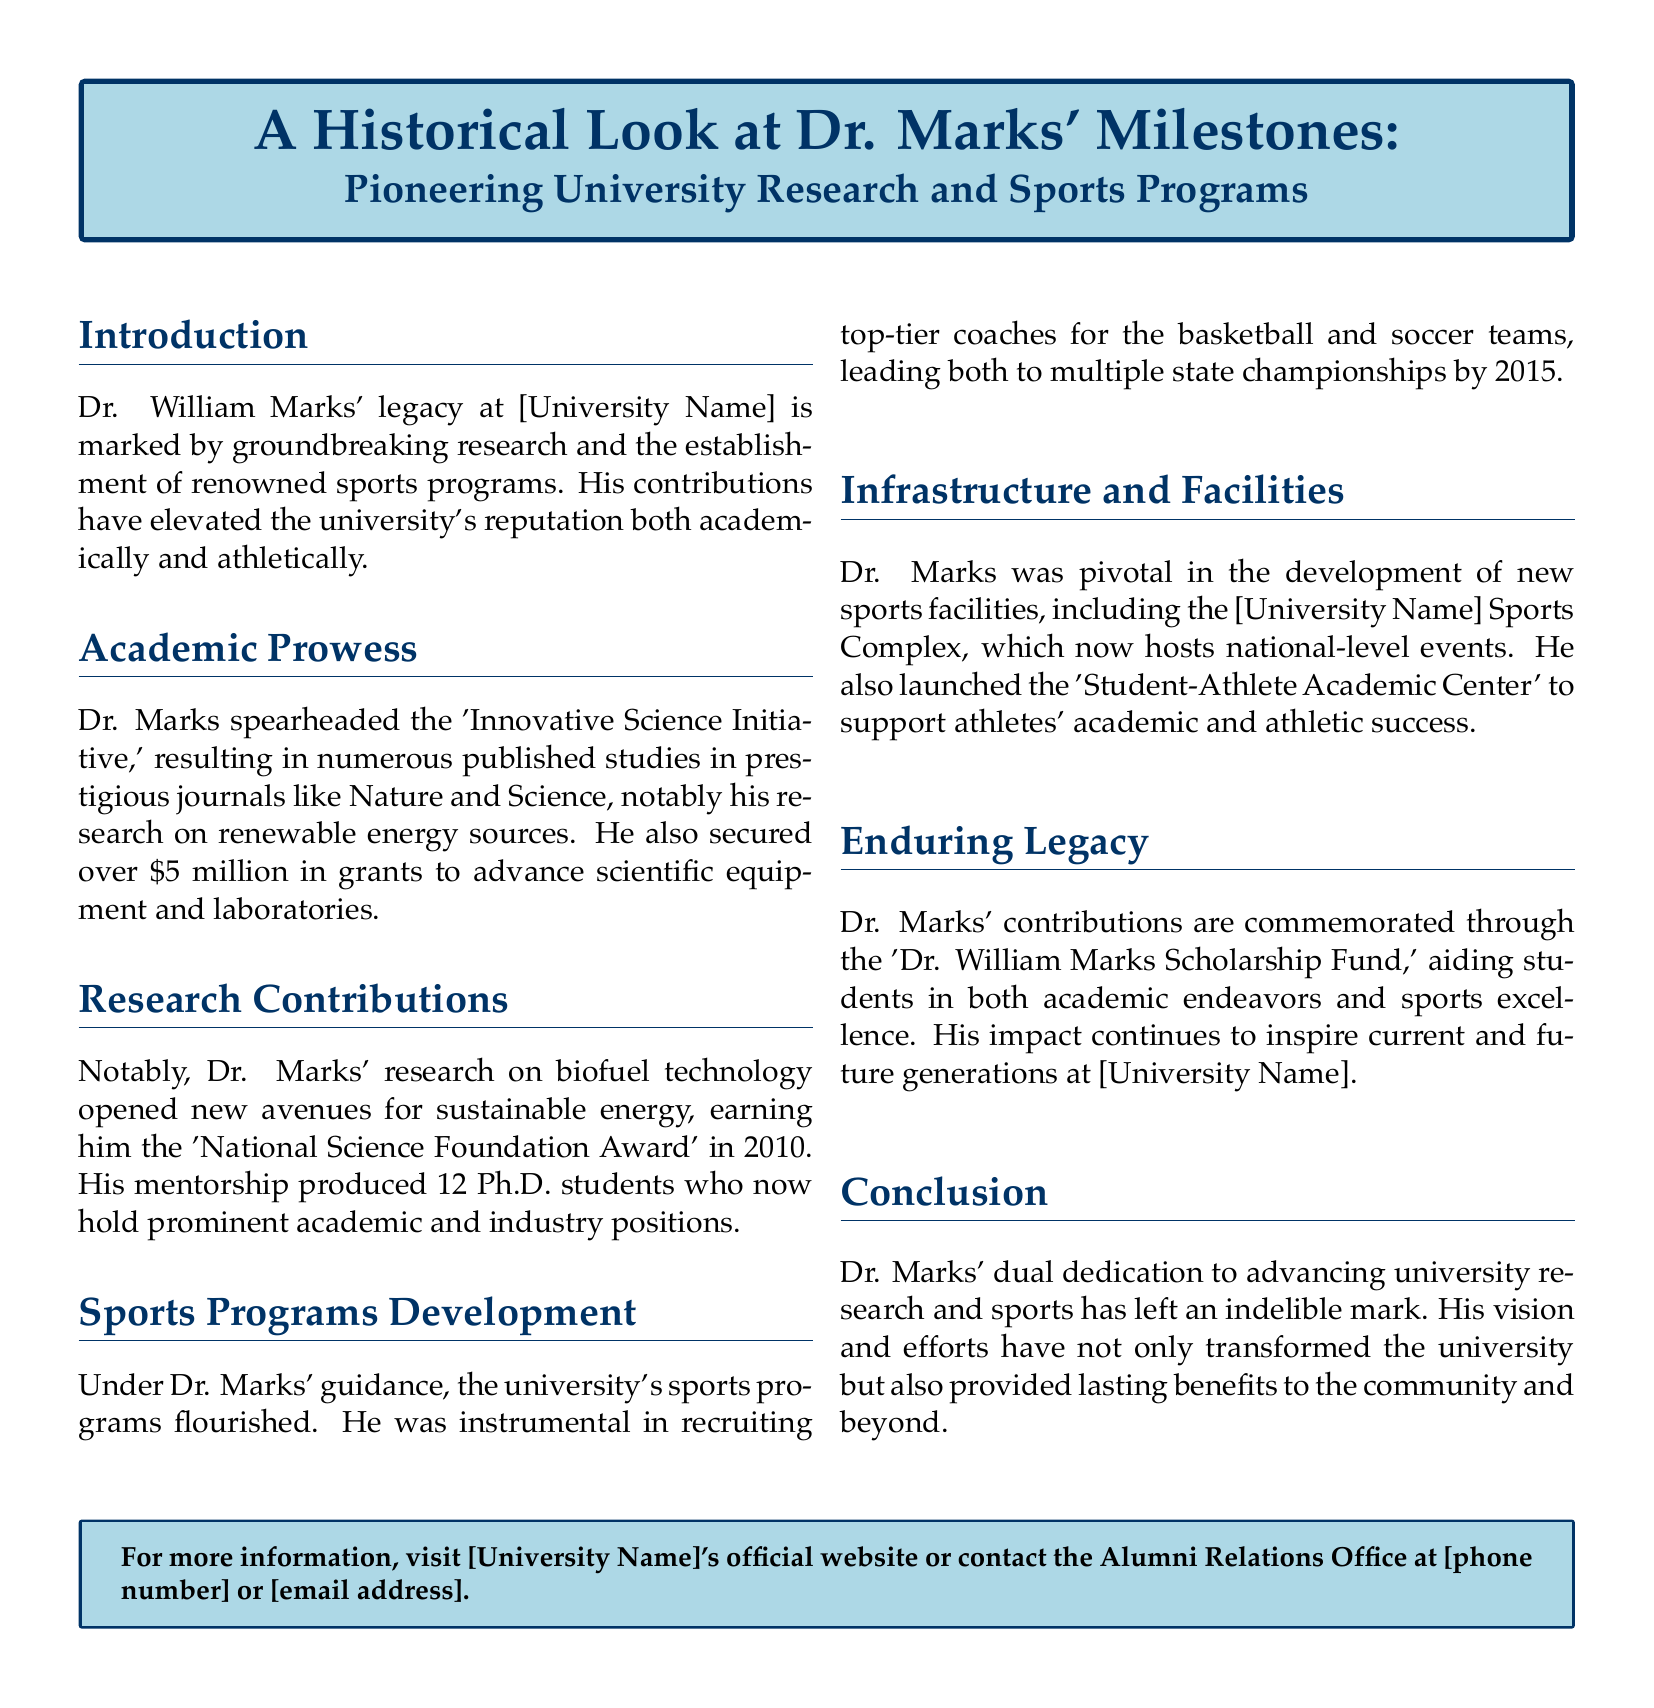What initiative did Dr. Marks spearhead? The document mentions that Dr. Marks spearheaded the 'Innovative Science Initiative.'
Answer: Innovative Science Initiative How much funding did Dr. Marks secure for research? The amount secured by Dr. Marks for research funding is over $5 million.
Answer: $5 million In what year did Dr. Marks receive the National Science Foundation Award? The document states that Dr. Marks earned the award in 2010.
Answer: 2010 What facility did Dr. Marks help develop for sports? Dr. Marks was pivotal in the development of the [University Name] Sports Complex.
Answer: [University Name] Sports Complex How many Ph.D. students did Dr. Marks mentor? According to the document, Dr. Marks mentored 12 Ph.D. students.
Answer: 12 What is the name of the scholarship fund established in Dr. Marks' honor? The document mentions the 'Dr. William Marks Scholarship Fund.'
Answer: Dr. William Marks Scholarship Fund What major achievements did the basketball and soccer teams accomplish under Dr. Marks? The basketball and soccer teams achieved multiple state championships by 2015.
Answer: Multiple state championships Which award did Dr. Marks receive for his biofuel technology research? Dr. Marks received the 'National Science Foundation Award' for his research.
Answer: National Science Foundation Award What center did Dr. Marks launch to support student-athletes? The document states that Dr. Marks launched the 'Student-Athlete Academic Center.'
Answer: Student-Athlete Academic Center 